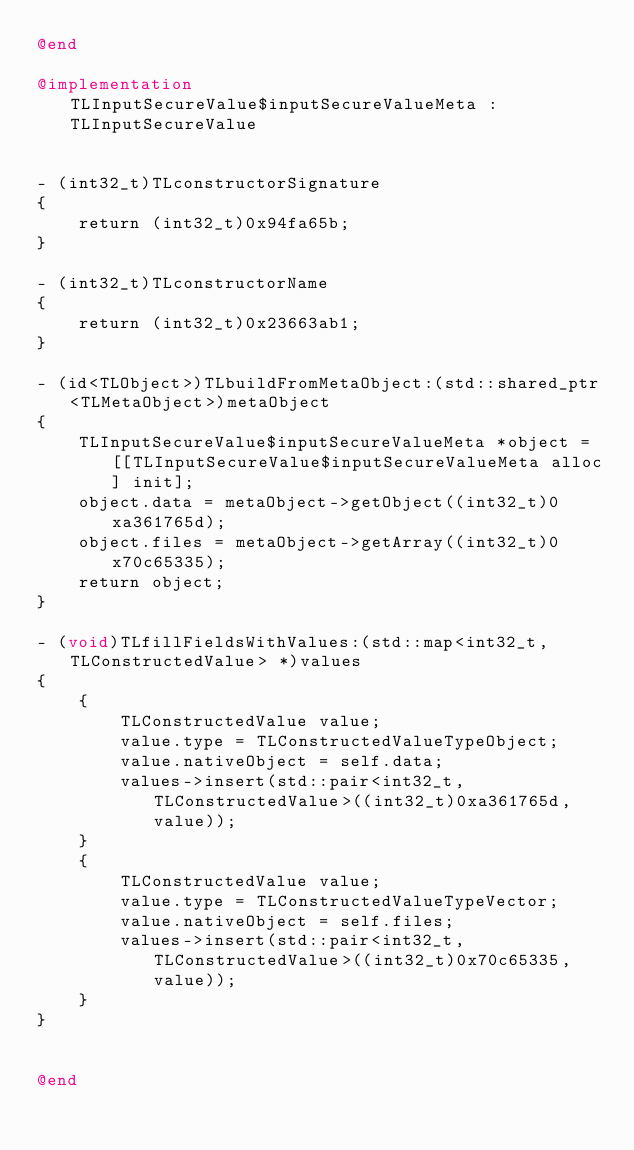<code> <loc_0><loc_0><loc_500><loc_500><_ObjectiveC_>@end

@implementation TLInputSecureValue$inputSecureValueMeta : TLInputSecureValue


- (int32_t)TLconstructorSignature
{
    return (int32_t)0x94fa65b;
}

- (int32_t)TLconstructorName
{
    return (int32_t)0x23663ab1;
}

- (id<TLObject>)TLbuildFromMetaObject:(std::shared_ptr<TLMetaObject>)metaObject
{
    TLInputSecureValue$inputSecureValueMeta *object = [[TLInputSecureValue$inputSecureValueMeta alloc] init];
    object.data = metaObject->getObject((int32_t)0xa361765d);
    object.files = metaObject->getArray((int32_t)0x70c65335);
    return object;
}

- (void)TLfillFieldsWithValues:(std::map<int32_t, TLConstructedValue> *)values
{
    {
        TLConstructedValue value;
        value.type = TLConstructedValueTypeObject;
        value.nativeObject = self.data;
        values->insert(std::pair<int32_t, TLConstructedValue>((int32_t)0xa361765d, value));
    }
    {
        TLConstructedValue value;
        value.type = TLConstructedValueTypeVector;
        value.nativeObject = self.files;
        values->insert(std::pair<int32_t, TLConstructedValue>((int32_t)0x70c65335, value));
    }
}


@end

</code> 